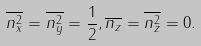Convert formula to latex. <formula><loc_0><loc_0><loc_500><loc_500>\overline { n _ { x } ^ { 2 } } = \overline { n _ { y } ^ { 2 } } = \frac { 1 } { 2 } , \overline { n _ { z } } = \overline { n _ { z } ^ { 2 } } = 0 .</formula> 